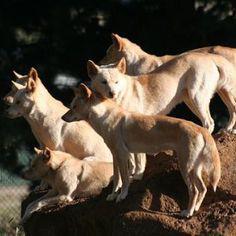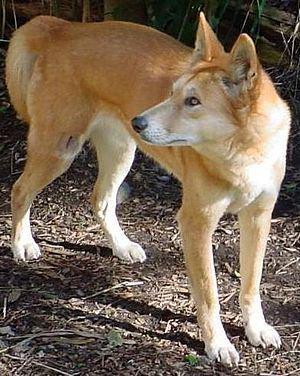The first image is the image on the left, the second image is the image on the right. Evaluate the accuracy of this statement regarding the images: "The wild dog in the image on the right is standing on all fours.". Is it true? Answer yes or no. Yes. The first image is the image on the left, the second image is the image on the right. Assess this claim about the two images: "An image shows at least one dog standing by a carcass.". Correct or not? Answer yes or no. No. 